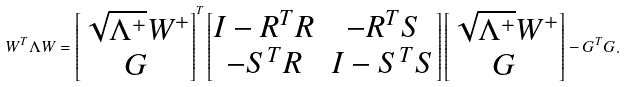Convert formula to latex. <formula><loc_0><loc_0><loc_500><loc_500>W ^ { T } \Lambda W = \begin{bmatrix} \sqrt { \Lambda ^ { + } } W ^ { + } \\ G \end{bmatrix} ^ { T } \begin{bmatrix} I - R ^ { T } R & - R ^ { T } S \\ - S ^ { T } R & I - S ^ { T } S \end{bmatrix} \begin{bmatrix} \sqrt { \Lambda ^ { + } } W ^ { + } \\ G \end{bmatrix} - G ^ { T } G .</formula> 